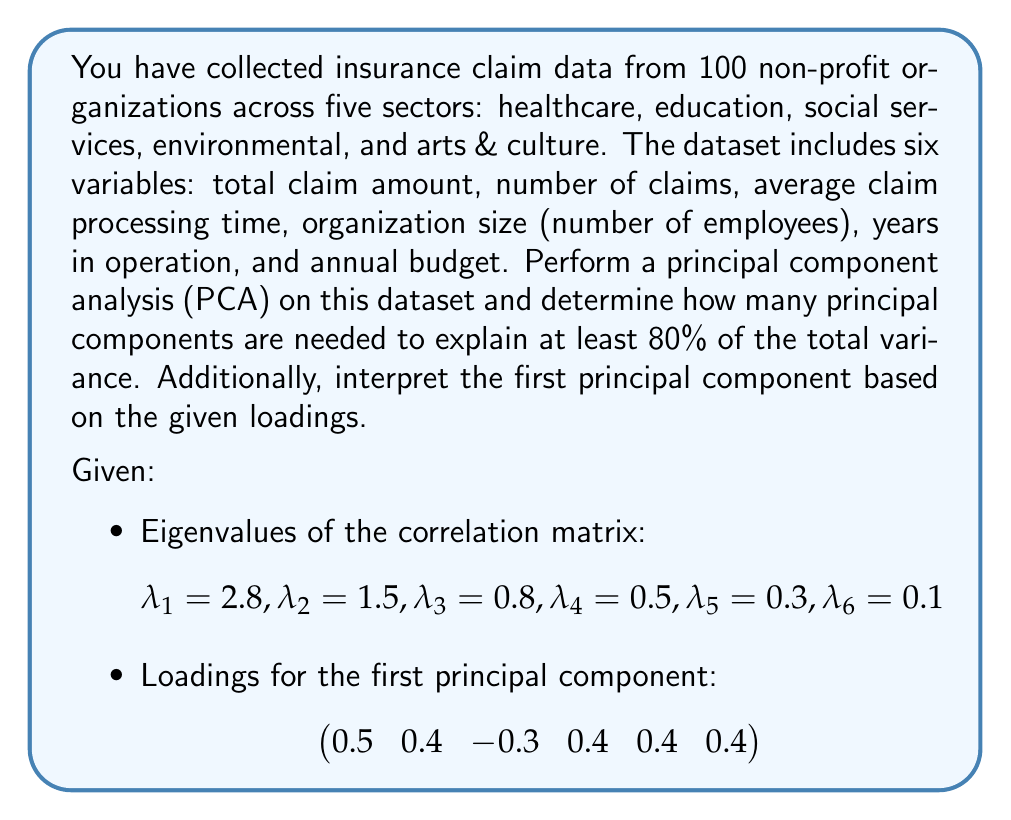Show me your answer to this math problem. To solve this problem, we'll follow these steps:

1) Calculate the total variance:
   $$\text{Total Variance} = \sum_{i=1}^6 \lambda_i = 2.8 + 1.5 + 0.8 + 0.5 + 0.3 + 0.1 = 6$$

2) Calculate the proportion of variance explained by each component:
   $$\text{Proportion}_i = \frac{\lambda_i}{\text{Total Variance}}$$
   
   For PC1: $\frac{2.8}{6} = 0.467$ or 46.7%
   For PC2: $\frac{1.5}{6} = 0.250$ or 25.0%
   For PC3: $\frac{0.8}{6} = 0.133$ or 13.3%
   For PC4: $\frac{0.5}{6} = 0.083$ or 8.3%
   For PC5: $\frac{0.3}{6} = 0.050$ or 5.0%
   For PC6: $\frac{0.1}{6} = 0.017$ or 1.7%

3) Calculate cumulative proportion of variance:
   PC1: 46.7%
   PC1 + PC2: 46.7% + 25.0% = 71.7%
   PC1 + PC2 + PC3: 71.7% + 13.3% = 85.0%

   We need 3 principal components to explain at least 80% of the total variance.

4) Interpret the first principal component:
   The loadings for PC1 are: [0.5, 0.4, -0.3, 0.4, 0.4, 0.4]
   
   All variables except the third (average claim processing time) have positive loadings of similar magnitude. The third variable has a negative loading. This suggests that PC1 represents an overall measure of the scale of insurance activity, where larger organizations with higher claim amounts, more claims, larger budgets, and longer operating histories tend to have shorter claim processing times.
Answer: 3 principal components; PC1 represents overall scale of insurance activity 